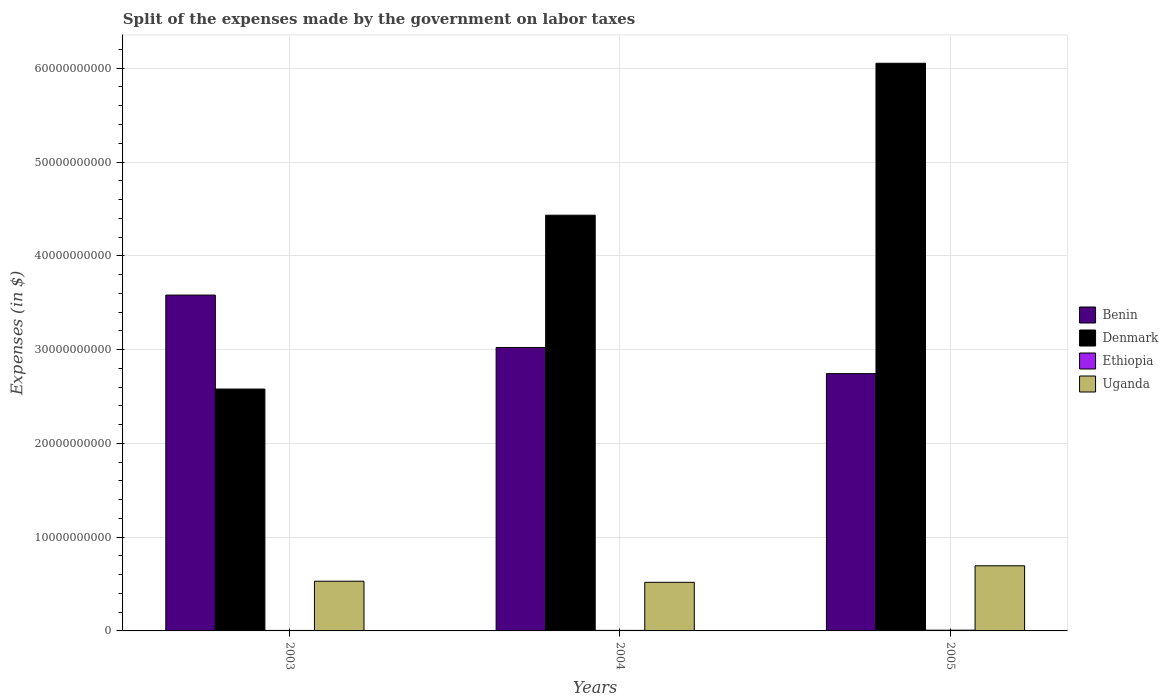How many different coloured bars are there?
Keep it short and to the point. 4. Are the number of bars per tick equal to the number of legend labels?
Offer a very short reply. Yes. How many bars are there on the 1st tick from the left?
Provide a succinct answer. 4. How many bars are there on the 1st tick from the right?
Make the answer very short. 4. What is the label of the 1st group of bars from the left?
Give a very brief answer. 2003. What is the expenses made by the government on labor taxes in Denmark in 2005?
Keep it short and to the point. 6.05e+1. Across all years, what is the maximum expenses made by the government on labor taxes in Uganda?
Ensure brevity in your answer.  6.95e+09. Across all years, what is the minimum expenses made by the government on labor taxes in Benin?
Keep it short and to the point. 2.74e+1. In which year was the expenses made by the government on labor taxes in Benin maximum?
Provide a short and direct response. 2003. What is the total expenses made by the government on labor taxes in Benin in the graph?
Your response must be concise. 9.35e+1. What is the difference between the expenses made by the government on labor taxes in Benin in 2003 and that in 2004?
Make the answer very short. 5.59e+09. What is the difference between the expenses made by the government on labor taxes in Uganda in 2005 and the expenses made by the government on labor taxes in Benin in 2004?
Ensure brevity in your answer.  -2.33e+1. What is the average expenses made by the government on labor taxes in Denmark per year?
Offer a terse response. 4.35e+1. In the year 2005, what is the difference between the expenses made by the government on labor taxes in Ethiopia and expenses made by the government on labor taxes in Denmark?
Keep it short and to the point. -6.05e+1. In how many years, is the expenses made by the government on labor taxes in Ethiopia greater than 24000000000 $?
Make the answer very short. 0. What is the ratio of the expenses made by the government on labor taxes in Ethiopia in 2003 to that in 2005?
Provide a succinct answer. 0.67. What is the difference between the highest and the second highest expenses made by the government on labor taxes in Denmark?
Your answer should be very brief. 1.62e+1. What is the difference between the highest and the lowest expenses made by the government on labor taxes in Uganda?
Provide a succinct answer. 1.76e+09. What does the 2nd bar from the left in 2003 represents?
Keep it short and to the point. Denmark. What does the 4th bar from the right in 2003 represents?
Your answer should be compact. Benin. Is it the case that in every year, the sum of the expenses made by the government on labor taxes in Ethiopia and expenses made by the government on labor taxes in Denmark is greater than the expenses made by the government on labor taxes in Uganda?
Offer a very short reply. Yes. Are all the bars in the graph horizontal?
Your answer should be very brief. No. How many years are there in the graph?
Provide a succinct answer. 3. What is the difference between two consecutive major ticks on the Y-axis?
Your response must be concise. 1.00e+1. Does the graph contain grids?
Provide a succinct answer. Yes. Where does the legend appear in the graph?
Offer a very short reply. Center right. What is the title of the graph?
Give a very brief answer. Split of the expenses made by the government on labor taxes. Does "Andorra" appear as one of the legend labels in the graph?
Give a very brief answer. No. What is the label or title of the Y-axis?
Offer a terse response. Expenses (in $). What is the Expenses (in $) of Benin in 2003?
Your response must be concise. 3.58e+1. What is the Expenses (in $) of Denmark in 2003?
Make the answer very short. 2.58e+1. What is the Expenses (in $) of Ethiopia in 2003?
Your response must be concise. 5.20e+07. What is the Expenses (in $) in Uganda in 2003?
Keep it short and to the point. 5.30e+09. What is the Expenses (in $) of Benin in 2004?
Ensure brevity in your answer.  3.02e+1. What is the Expenses (in $) in Denmark in 2004?
Keep it short and to the point. 4.43e+1. What is the Expenses (in $) in Ethiopia in 2004?
Offer a terse response. 5.71e+07. What is the Expenses (in $) of Uganda in 2004?
Provide a short and direct response. 5.18e+09. What is the Expenses (in $) of Benin in 2005?
Provide a succinct answer. 2.74e+1. What is the Expenses (in $) of Denmark in 2005?
Provide a succinct answer. 6.05e+1. What is the Expenses (in $) of Ethiopia in 2005?
Your response must be concise. 7.71e+07. What is the Expenses (in $) in Uganda in 2005?
Your answer should be compact. 6.95e+09. Across all years, what is the maximum Expenses (in $) in Benin?
Keep it short and to the point. 3.58e+1. Across all years, what is the maximum Expenses (in $) in Denmark?
Ensure brevity in your answer.  6.05e+1. Across all years, what is the maximum Expenses (in $) of Ethiopia?
Make the answer very short. 7.71e+07. Across all years, what is the maximum Expenses (in $) of Uganda?
Make the answer very short. 6.95e+09. Across all years, what is the minimum Expenses (in $) in Benin?
Give a very brief answer. 2.74e+1. Across all years, what is the minimum Expenses (in $) of Denmark?
Your response must be concise. 2.58e+1. Across all years, what is the minimum Expenses (in $) of Ethiopia?
Offer a terse response. 5.20e+07. Across all years, what is the minimum Expenses (in $) of Uganda?
Your response must be concise. 5.18e+09. What is the total Expenses (in $) of Benin in the graph?
Offer a terse response. 9.35e+1. What is the total Expenses (in $) in Denmark in the graph?
Your answer should be compact. 1.31e+11. What is the total Expenses (in $) in Ethiopia in the graph?
Ensure brevity in your answer.  1.86e+08. What is the total Expenses (in $) of Uganda in the graph?
Offer a terse response. 1.74e+1. What is the difference between the Expenses (in $) of Benin in 2003 and that in 2004?
Keep it short and to the point. 5.59e+09. What is the difference between the Expenses (in $) in Denmark in 2003 and that in 2004?
Provide a short and direct response. -1.85e+1. What is the difference between the Expenses (in $) of Ethiopia in 2003 and that in 2004?
Make the answer very short. -5.10e+06. What is the difference between the Expenses (in $) of Uganda in 2003 and that in 2004?
Offer a terse response. 1.18e+08. What is the difference between the Expenses (in $) in Benin in 2003 and that in 2005?
Offer a terse response. 8.38e+09. What is the difference between the Expenses (in $) of Denmark in 2003 and that in 2005?
Give a very brief answer. -3.47e+1. What is the difference between the Expenses (in $) in Ethiopia in 2003 and that in 2005?
Your response must be concise. -2.51e+07. What is the difference between the Expenses (in $) in Uganda in 2003 and that in 2005?
Your response must be concise. -1.65e+09. What is the difference between the Expenses (in $) in Benin in 2004 and that in 2005?
Provide a short and direct response. 2.79e+09. What is the difference between the Expenses (in $) in Denmark in 2004 and that in 2005?
Your answer should be very brief. -1.62e+1. What is the difference between the Expenses (in $) of Ethiopia in 2004 and that in 2005?
Your answer should be compact. -2.00e+07. What is the difference between the Expenses (in $) in Uganda in 2004 and that in 2005?
Your answer should be compact. -1.76e+09. What is the difference between the Expenses (in $) of Benin in 2003 and the Expenses (in $) of Denmark in 2004?
Keep it short and to the point. -8.51e+09. What is the difference between the Expenses (in $) in Benin in 2003 and the Expenses (in $) in Ethiopia in 2004?
Ensure brevity in your answer.  3.58e+1. What is the difference between the Expenses (in $) in Benin in 2003 and the Expenses (in $) in Uganda in 2004?
Your answer should be very brief. 3.06e+1. What is the difference between the Expenses (in $) in Denmark in 2003 and the Expenses (in $) in Ethiopia in 2004?
Ensure brevity in your answer.  2.57e+1. What is the difference between the Expenses (in $) in Denmark in 2003 and the Expenses (in $) in Uganda in 2004?
Ensure brevity in your answer.  2.06e+1. What is the difference between the Expenses (in $) of Ethiopia in 2003 and the Expenses (in $) of Uganda in 2004?
Offer a very short reply. -5.13e+09. What is the difference between the Expenses (in $) of Benin in 2003 and the Expenses (in $) of Denmark in 2005?
Your response must be concise. -2.47e+1. What is the difference between the Expenses (in $) of Benin in 2003 and the Expenses (in $) of Ethiopia in 2005?
Provide a succinct answer. 3.57e+1. What is the difference between the Expenses (in $) in Benin in 2003 and the Expenses (in $) in Uganda in 2005?
Provide a short and direct response. 2.89e+1. What is the difference between the Expenses (in $) of Denmark in 2003 and the Expenses (in $) of Ethiopia in 2005?
Keep it short and to the point. 2.57e+1. What is the difference between the Expenses (in $) in Denmark in 2003 and the Expenses (in $) in Uganda in 2005?
Offer a very short reply. 1.88e+1. What is the difference between the Expenses (in $) of Ethiopia in 2003 and the Expenses (in $) of Uganda in 2005?
Your response must be concise. -6.89e+09. What is the difference between the Expenses (in $) in Benin in 2004 and the Expenses (in $) in Denmark in 2005?
Ensure brevity in your answer.  -3.03e+1. What is the difference between the Expenses (in $) of Benin in 2004 and the Expenses (in $) of Ethiopia in 2005?
Your response must be concise. 3.01e+1. What is the difference between the Expenses (in $) of Benin in 2004 and the Expenses (in $) of Uganda in 2005?
Give a very brief answer. 2.33e+1. What is the difference between the Expenses (in $) in Denmark in 2004 and the Expenses (in $) in Ethiopia in 2005?
Ensure brevity in your answer.  4.42e+1. What is the difference between the Expenses (in $) of Denmark in 2004 and the Expenses (in $) of Uganda in 2005?
Offer a terse response. 3.74e+1. What is the difference between the Expenses (in $) in Ethiopia in 2004 and the Expenses (in $) in Uganda in 2005?
Provide a short and direct response. -6.89e+09. What is the average Expenses (in $) in Benin per year?
Keep it short and to the point. 3.12e+1. What is the average Expenses (in $) of Denmark per year?
Give a very brief answer. 4.35e+1. What is the average Expenses (in $) in Ethiopia per year?
Offer a very short reply. 6.21e+07. What is the average Expenses (in $) in Uganda per year?
Your response must be concise. 5.81e+09. In the year 2003, what is the difference between the Expenses (in $) of Benin and Expenses (in $) of Denmark?
Your answer should be compact. 1.00e+1. In the year 2003, what is the difference between the Expenses (in $) of Benin and Expenses (in $) of Ethiopia?
Give a very brief answer. 3.58e+1. In the year 2003, what is the difference between the Expenses (in $) of Benin and Expenses (in $) of Uganda?
Make the answer very short. 3.05e+1. In the year 2003, what is the difference between the Expenses (in $) of Denmark and Expenses (in $) of Ethiopia?
Make the answer very short. 2.57e+1. In the year 2003, what is the difference between the Expenses (in $) in Denmark and Expenses (in $) in Uganda?
Make the answer very short. 2.05e+1. In the year 2003, what is the difference between the Expenses (in $) in Ethiopia and Expenses (in $) in Uganda?
Ensure brevity in your answer.  -5.25e+09. In the year 2004, what is the difference between the Expenses (in $) of Benin and Expenses (in $) of Denmark?
Provide a succinct answer. -1.41e+1. In the year 2004, what is the difference between the Expenses (in $) of Benin and Expenses (in $) of Ethiopia?
Keep it short and to the point. 3.02e+1. In the year 2004, what is the difference between the Expenses (in $) of Benin and Expenses (in $) of Uganda?
Make the answer very short. 2.50e+1. In the year 2004, what is the difference between the Expenses (in $) of Denmark and Expenses (in $) of Ethiopia?
Offer a terse response. 4.43e+1. In the year 2004, what is the difference between the Expenses (in $) of Denmark and Expenses (in $) of Uganda?
Your answer should be very brief. 3.91e+1. In the year 2004, what is the difference between the Expenses (in $) of Ethiopia and Expenses (in $) of Uganda?
Offer a terse response. -5.12e+09. In the year 2005, what is the difference between the Expenses (in $) of Benin and Expenses (in $) of Denmark?
Offer a very short reply. -3.31e+1. In the year 2005, what is the difference between the Expenses (in $) of Benin and Expenses (in $) of Ethiopia?
Provide a short and direct response. 2.74e+1. In the year 2005, what is the difference between the Expenses (in $) of Benin and Expenses (in $) of Uganda?
Your answer should be very brief. 2.05e+1. In the year 2005, what is the difference between the Expenses (in $) of Denmark and Expenses (in $) of Ethiopia?
Provide a short and direct response. 6.05e+1. In the year 2005, what is the difference between the Expenses (in $) in Denmark and Expenses (in $) in Uganda?
Provide a succinct answer. 5.36e+1. In the year 2005, what is the difference between the Expenses (in $) of Ethiopia and Expenses (in $) of Uganda?
Your answer should be very brief. -6.87e+09. What is the ratio of the Expenses (in $) of Benin in 2003 to that in 2004?
Keep it short and to the point. 1.19. What is the ratio of the Expenses (in $) of Denmark in 2003 to that in 2004?
Provide a succinct answer. 0.58. What is the ratio of the Expenses (in $) of Ethiopia in 2003 to that in 2004?
Ensure brevity in your answer.  0.91. What is the ratio of the Expenses (in $) in Uganda in 2003 to that in 2004?
Give a very brief answer. 1.02. What is the ratio of the Expenses (in $) in Benin in 2003 to that in 2005?
Provide a succinct answer. 1.31. What is the ratio of the Expenses (in $) in Denmark in 2003 to that in 2005?
Ensure brevity in your answer.  0.43. What is the ratio of the Expenses (in $) of Ethiopia in 2003 to that in 2005?
Give a very brief answer. 0.67. What is the ratio of the Expenses (in $) in Uganda in 2003 to that in 2005?
Offer a very short reply. 0.76. What is the ratio of the Expenses (in $) of Benin in 2004 to that in 2005?
Ensure brevity in your answer.  1.1. What is the ratio of the Expenses (in $) of Denmark in 2004 to that in 2005?
Provide a succinct answer. 0.73. What is the ratio of the Expenses (in $) in Ethiopia in 2004 to that in 2005?
Offer a very short reply. 0.74. What is the ratio of the Expenses (in $) in Uganda in 2004 to that in 2005?
Ensure brevity in your answer.  0.75. What is the difference between the highest and the second highest Expenses (in $) of Benin?
Your answer should be very brief. 5.59e+09. What is the difference between the highest and the second highest Expenses (in $) of Denmark?
Keep it short and to the point. 1.62e+1. What is the difference between the highest and the second highest Expenses (in $) of Ethiopia?
Your response must be concise. 2.00e+07. What is the difference between the highest and the second highest Expenses (in $) in Uganda?
Keep it short and to the point. 1.65e+09. What is the difference between the highest and the lowest Expenses (in $) of Benin?
Provide a short and direct response. 8.38e+09. What is the difference between the highest and the lowest Expenses (in $) in Denmark?
Your answer should be compact. 3.47e+1. What is the difference between the highest and the lowest Expenses (in $) in Ethiopia?
Offer a very short reply. 2.51e+07. What is the difference between the highest and the lowest Expenses (in $) in Uganda?
Make the answer very short. 1.76e+09. 